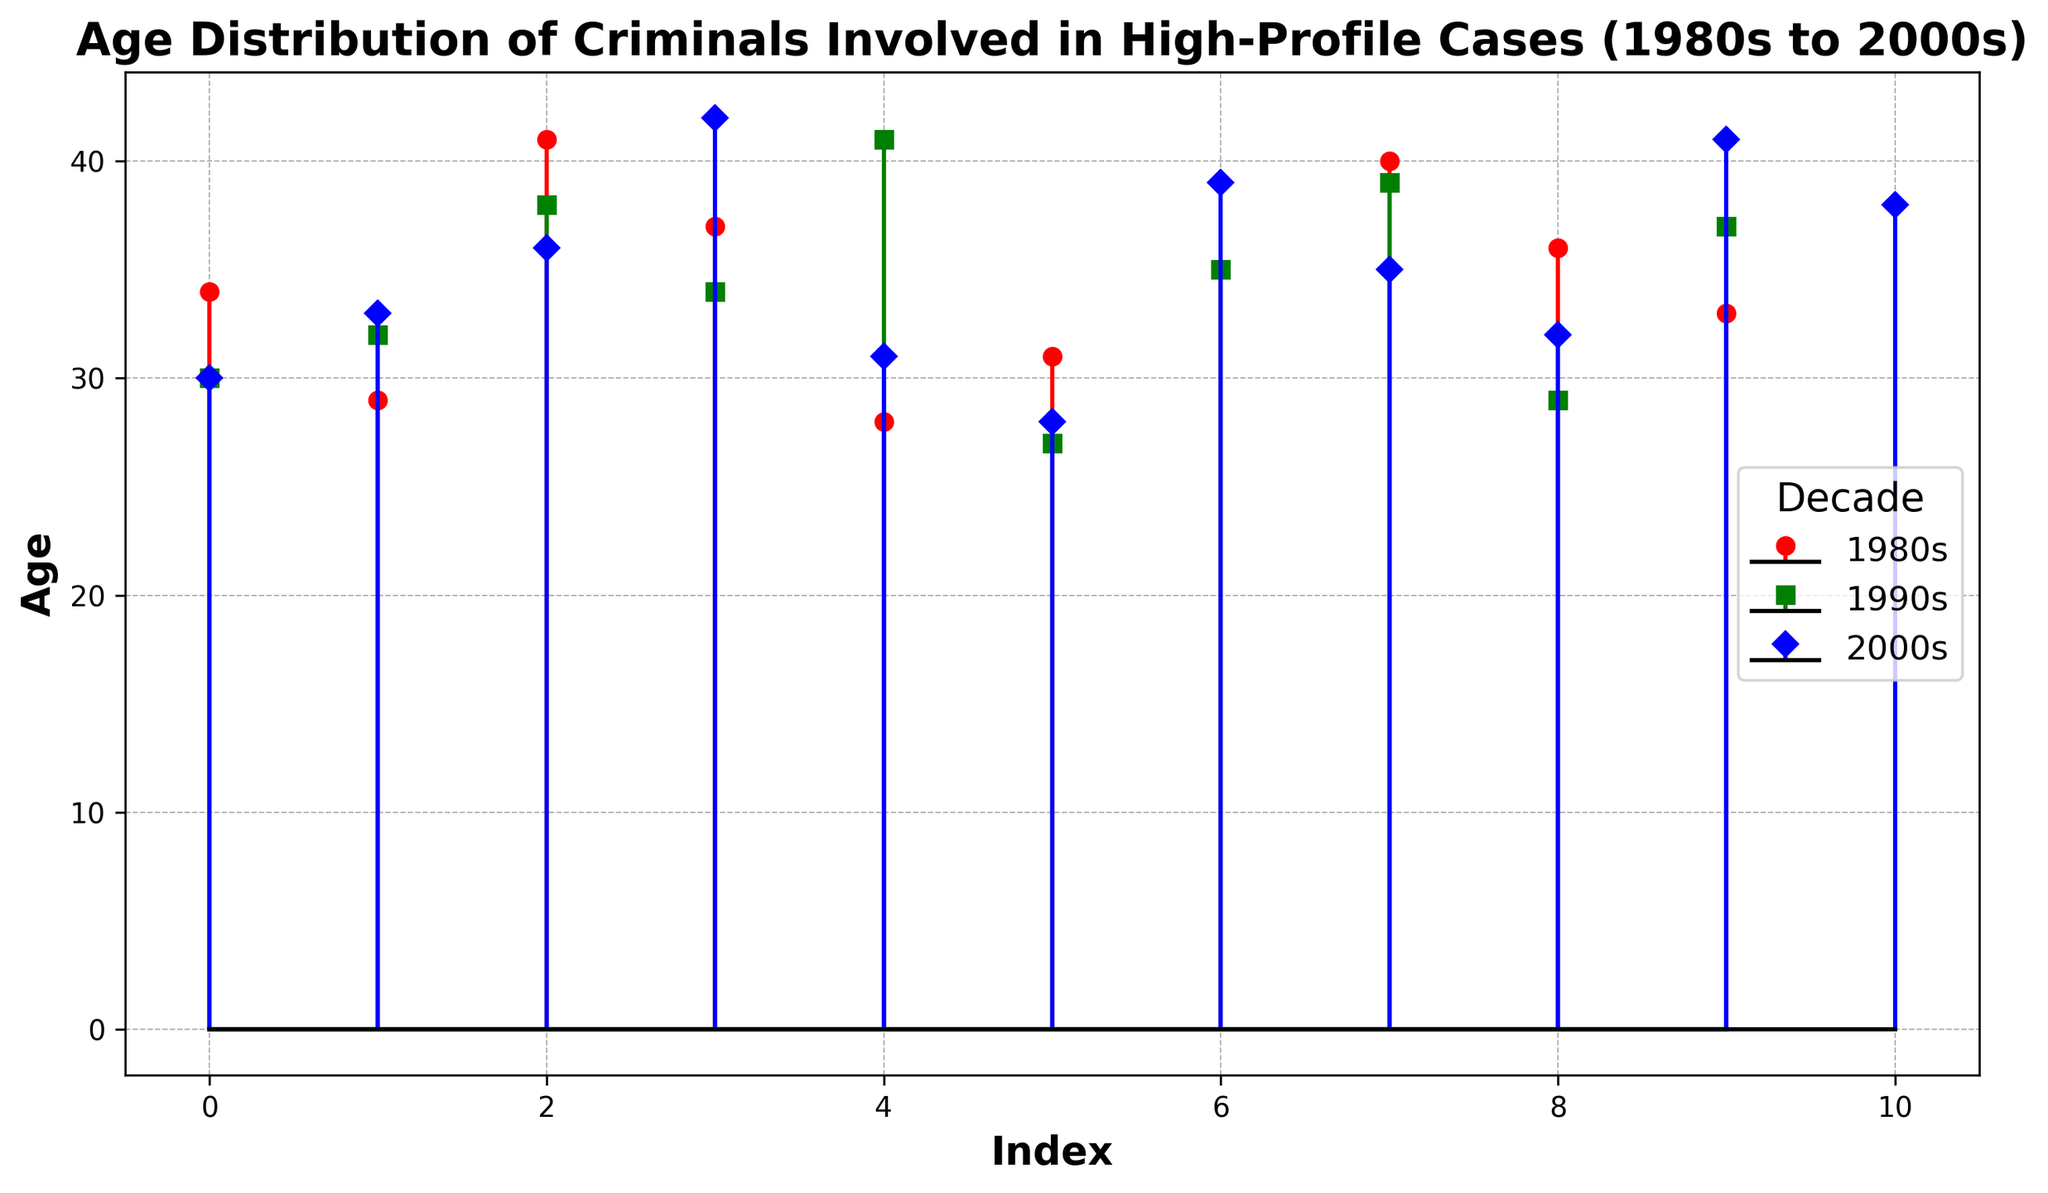What is the range of ages recorded for criminals in the 1980s? To find the range of ages for the 1980s, identify the minimum and maximum ages plotted for this decade. From the plot, the minimum age among the 1980s data points is 28, and the maximum is 41. Thus, the range is the difference between these two values, which is 41 - 28.
Answer: 13 Which decade shows the widest variation in age distribution? To determine the widest variation in age distribution, we need to compare the range of ages across the three decades. From the plot:
- The 1980s range is from 28 to 41 (range = 13).
- The 1990s range is from 27 to 41 (range = 14).
- The 2000s range is from 28 to 42 (range = 14).
The widest variations are in the 1990s and 2000s, where the range of ages is 14.
Answer: 1990s and 2000s What is the average age of criminals in the 2000s? To calculate the average age of criminals in the 2000s, sum all the age values for that decade and divide by the count of ages. From the figure, ages are: [30, 33, 36, 42, 31, 28, 39, 35, 32, 41, 38]. The total sum is 385, and there are 11 values. Thus, the average is 385 / 11.
Answer: 35 Which decade had the oldest criminal involved in high-profile cases? Identify the maximum age from each decade's data in the plot:
- The 1980s maximum age is 41.
- The 1990s maximum age is 41.
- The 2000s maximum age is 42.
Thus, the 2000s had the oldest criminal at age 42.
Answer: 2000s How many criminals in the 1990s were younger than 30 years old? From the plot, the ages in the 1990s that are under 30 are 30, 32, 38, 34, 41, 27, 35, 39, 29, 37. Here, the ages below 30 are 27 and 29. Count these values to get the answer.
Answer: 2 Compare the median age of criminals in the 1980s and 2000s. To find the median age for each decade, order the ages and find the middle number. For the 1980s (ages: [28, 29, 31, 33, 34, 35, 36, 37, 40, 41]), the middle value is between 34 and 35, so the median is (34+35)/2 = 34.5. For the 2000s (ages: [28, 30, 31, 32, 33, 35, 36, 38, 39, 41, 42]), the middle value is 35.
Answer: 1980s: 34.5, 2000s: 35 Which decade has the highest concentration of ages between 30 and 40? To determine the decade with the highest concentration of ages between 30 and 40, count the number of ages that fall within this interval for each decade from the plot. 
- 1980s: [34, 31, 35, 36, 33], total = 5
- 1990s: [30, 32, 34, 35, 39, 37], total = 6
- 2000s: [30, 33, 36, 31, 39, 35, 32, 38], total = 8
Thus, the 2000s have the highest concentration.
Answer: 2000s 